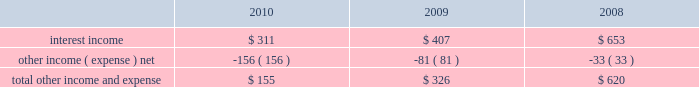Table of contents research and development expense ( 201cr&d 201d ) r&d expense increased 34% ( 34 % ) or $ 449 million to $ 1.8 billion in 2010 compared to 2009 .
This increase was due primarily to an increase in headcount and related expenses in the current year to support expanded r&d activities .
Also contributing to this increase in r&d expense in 2010 was the capitalization in 2009 of software development costs of $ 71 million related to mac os x snow leopard .
Although total r&d expense increased 34% ( 34 % ) during 2010 , it declined as a percentage of net sales given the 52% ( 52 % ) year-over-year increase in net sales in 2010 .
The company continues to believe that focused investments in r&d are critical to its future growth and competitive position in the marketplace and are directly related to timely development of new and enhanced products that are central to the company 2019s core business strategy .
As such , the company expects to make further investments in r&d to remain competitive .
R&d expense increased 20% ( 20 % ) or $ 224 million to $ 1.3 billion in 2009 compared to 2008 .
This increase was due primarily to an increase in headcount in 2009 to support expanded r&d activities and higher stock-based compensation expenses .
Additionally , $ 71 million of software development costs were capitalized related to mac os x snow leopard and excluded from r&d expense during 2009 , compared to $ 11 million of software development costs capitalized during 2008 .
Although total r&d expense increased 20% ( 20 % ) during 2009 , it remained relatively flat as a percentage of net sales given the 14% ( 14 % ) increase in revenue in 2009 .
Selling , general and administrative expense ( 201csg&a 201d ) sg&a expense increased $ 1.4 billion or 33% ( 33 % ) to $ 5.5 billion in 2010 compared to 2009 .
This increase was due primarily to the company 2019s continued expansion of its retail segment , higher spending on marketing and advertising programs , increased stock-based compensation expenses and variable costs associated with the overall growth of the company 2019s net sales .
Sg&a expenses increased $ 388 million or 10% ( 10 % ) to $ 4.1 billion in 2009 compared to 2008 .
This increase was due primarily to the company 2019s continued expansion of its retail segment in both domestic and international markets , higher stock-based compensation expense and higher spending on marketing and advertising .
Other income and expense other income and expense for the three years ended september 25 , 2010 , are as follows ( in millions ) : total other income and expense decreased $ 171 million or 52% ( 52 % ) to $ 155 million during 2010 compared to $ 326 million and $ 620 million in 2009 and 2008 , respectively .
The overall decrease in other income and expense is attributable to the significant declines in interest rates on a year- over-year basis , partially offset by the company 2019s higher cash , cash equivalents and marketable securities balances .
The weighted average interest rate earned by the company on its cash , cash equivalents and marketable securities was 0.75% ( 0.75 % ) , 1.43% ( 1.43 % ) and 3.44% ( 3.44 % ) during 2010 , 2009 and 2008 , respectively .
Additionally the company incurred higher premium expenses on its foreign exchange option contracts , which further reduced the total other income and expense .
During 2010 , 2009 and 2008 , the company had no debt outstanding and accordingly did not incur any related interest expense .
Provision for income taxes the company 2019s effective tax rates were 24% ( 24 % ) , 32% ( 32 % ) and 32% ( 32 % ) for 2010 , 2009 and 2008 , respectively .
The company 2019s effective rates for these periods differ from the statutory federal income tax rate of 35% ( 35 % ) due .

By how much did total other income and expense decrease from 2008 to 2009? 
Computations: ((620 - 326) / 620)
Answer: 0.47419. 